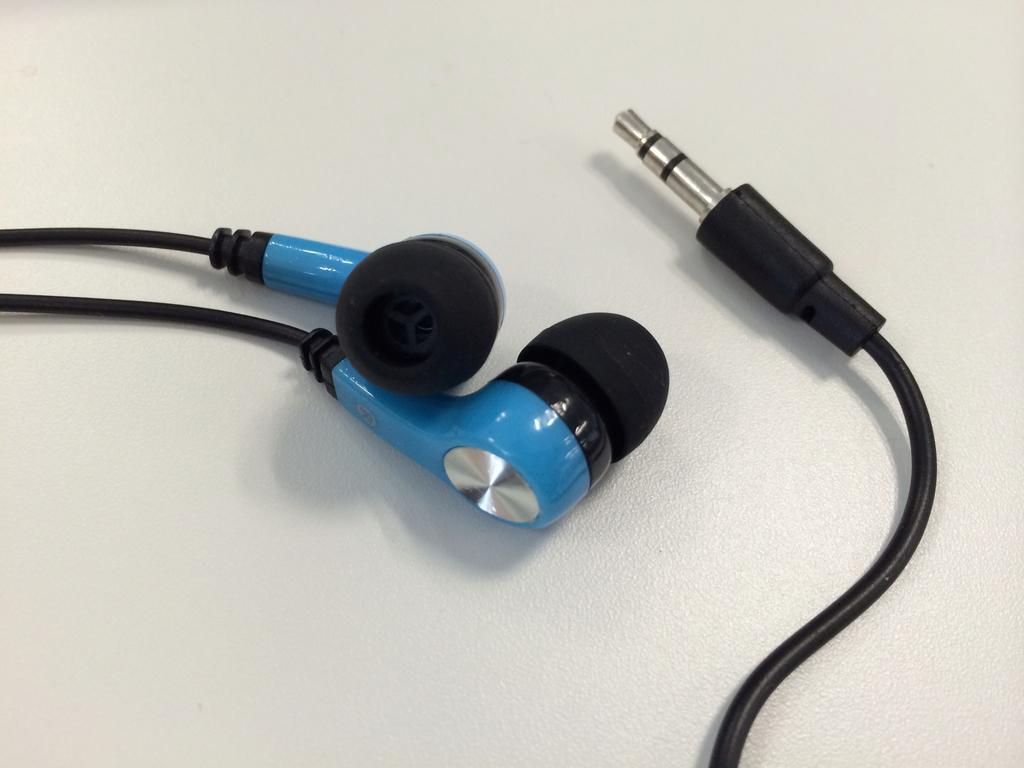Please provide a concise description of this image. In this image we can see headphones on the white colored surface. 